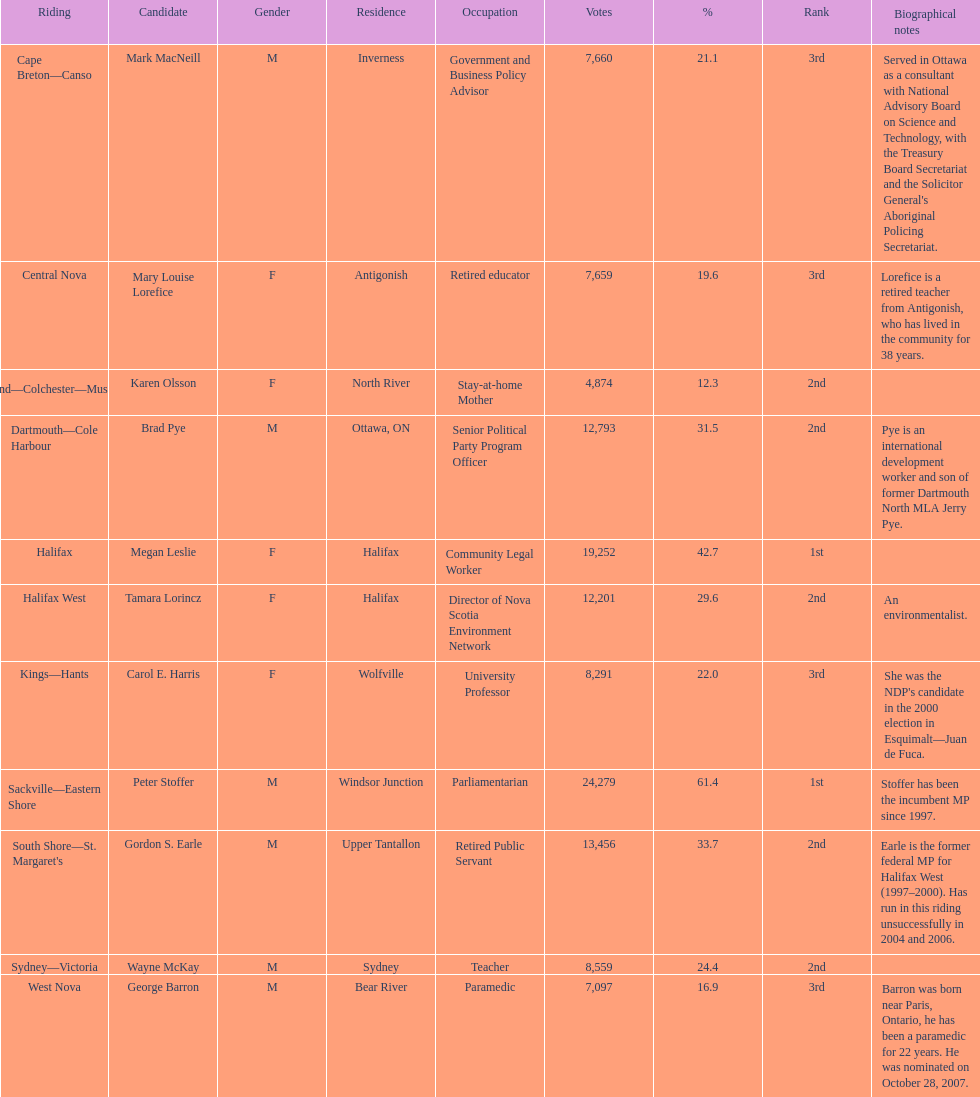Parse the full table in json format. {'header': ['Riding', 'Candidate', 'Gender', 'Residence', 'Occupation', 'Votes', '%', 'Rank', 'Biographical notes'], 'rows': [['Cape Breton—Canso', 'Mark MacNeill', 'M', 'Inverness', 'Government and Business Policy Advisor', '7,660', '21.1', '3rd', "Served in Ottawa as a consultant with National Advisory Board on Science and Technology, with the Treasury Board Secretariat and the Solicitor General's Aboriginal Policing Secretariat."], ['Central Nova', 'Mary Louise Lorefice', 'F', 'Antigonish', 'Retired educator', '7,659', '19.6', '3rd', 'Lorefice is a retired teacher from Antigonish, who has lived in the community for 38 years.'], ['Cumberland—Colchester—Musquodoboit Valley', 'Karen Olsson', 'F', 'North River', 'Stay-at-home Mother', '4,874', '12.3', '2nd', ''], ['Dartmouth—Cole Harbour', 'Brad Pye', 'M', 'Ottawa, ON', 'Senior Political Party Program Officer', '12,793', '31.5', '2nd', 'Pye is an international development worker and son of former Dartmouth North MLA Jerry Pye.'], ['Halifax', 'Megan Leslie', 'F', 'Halifax', 'Community Legal Worker', '19,252', '42.7', '1st', ''], ['Halifax West', 'Tamara Lorincz', 'F', 'Halifax', 'Director of Nova Scotia Environment Network', '12,201', '29.6', '2nd', 'An environmentalist.'], ['Kings—Hants', 'Carol E. Harris', 'F', 'Wolfville', 'University Professor', '8,291', '22.0', '3rd', "She was the NDP's candidate in the 2000 election in Esquimalt—Juan de Fuca."], ['Sackville—Eastern Shore', 'Peter Stoffer', 'M', 'Windsor Junction', 'Parliamentarian', '24,279', '61.4', '1st', 'Stoffer has been the incumbent MP since 1997.'], ["South Shore—St. Margaret's", 'Gordon S. Earle', 'M', 'Upper Tantallon', 'Retired Public Servant', '13,456', '33.7', '2nd', 'Earle is the former federal MP for Halifax West (1997–2000). Has run in this riding unsuccessfully in 2004 and 2006.'], ['Sydney—Victoria', 'Wayne McKay', 'M', 'Sydney', 'Teacher', '8,559', '24.4', '2nd', ''], ['West Nova', 'George Barron', 'M', 'Bear River', 'Paramedic', '7,097', '16.9', '3rd', 'Barron was born near Paris, Ontario, he has been a paramedic for 22 years. He was nominated on October 28, 2007.']]} Who were the complete list of new democratic party candidates in the 2008 canadian federal election? Mark MacNeill, Mary Louise Lorefice, Karen Olsson, Brad Pye, Megan Leslie, Tamara Lorincz, Carol E. Harris, Peter Stoffer, Gordon S. Earle, Wayne McKay, George Barron. And, between mark macneill and karen olsson, who secured more votes? Mark MacNeill. 